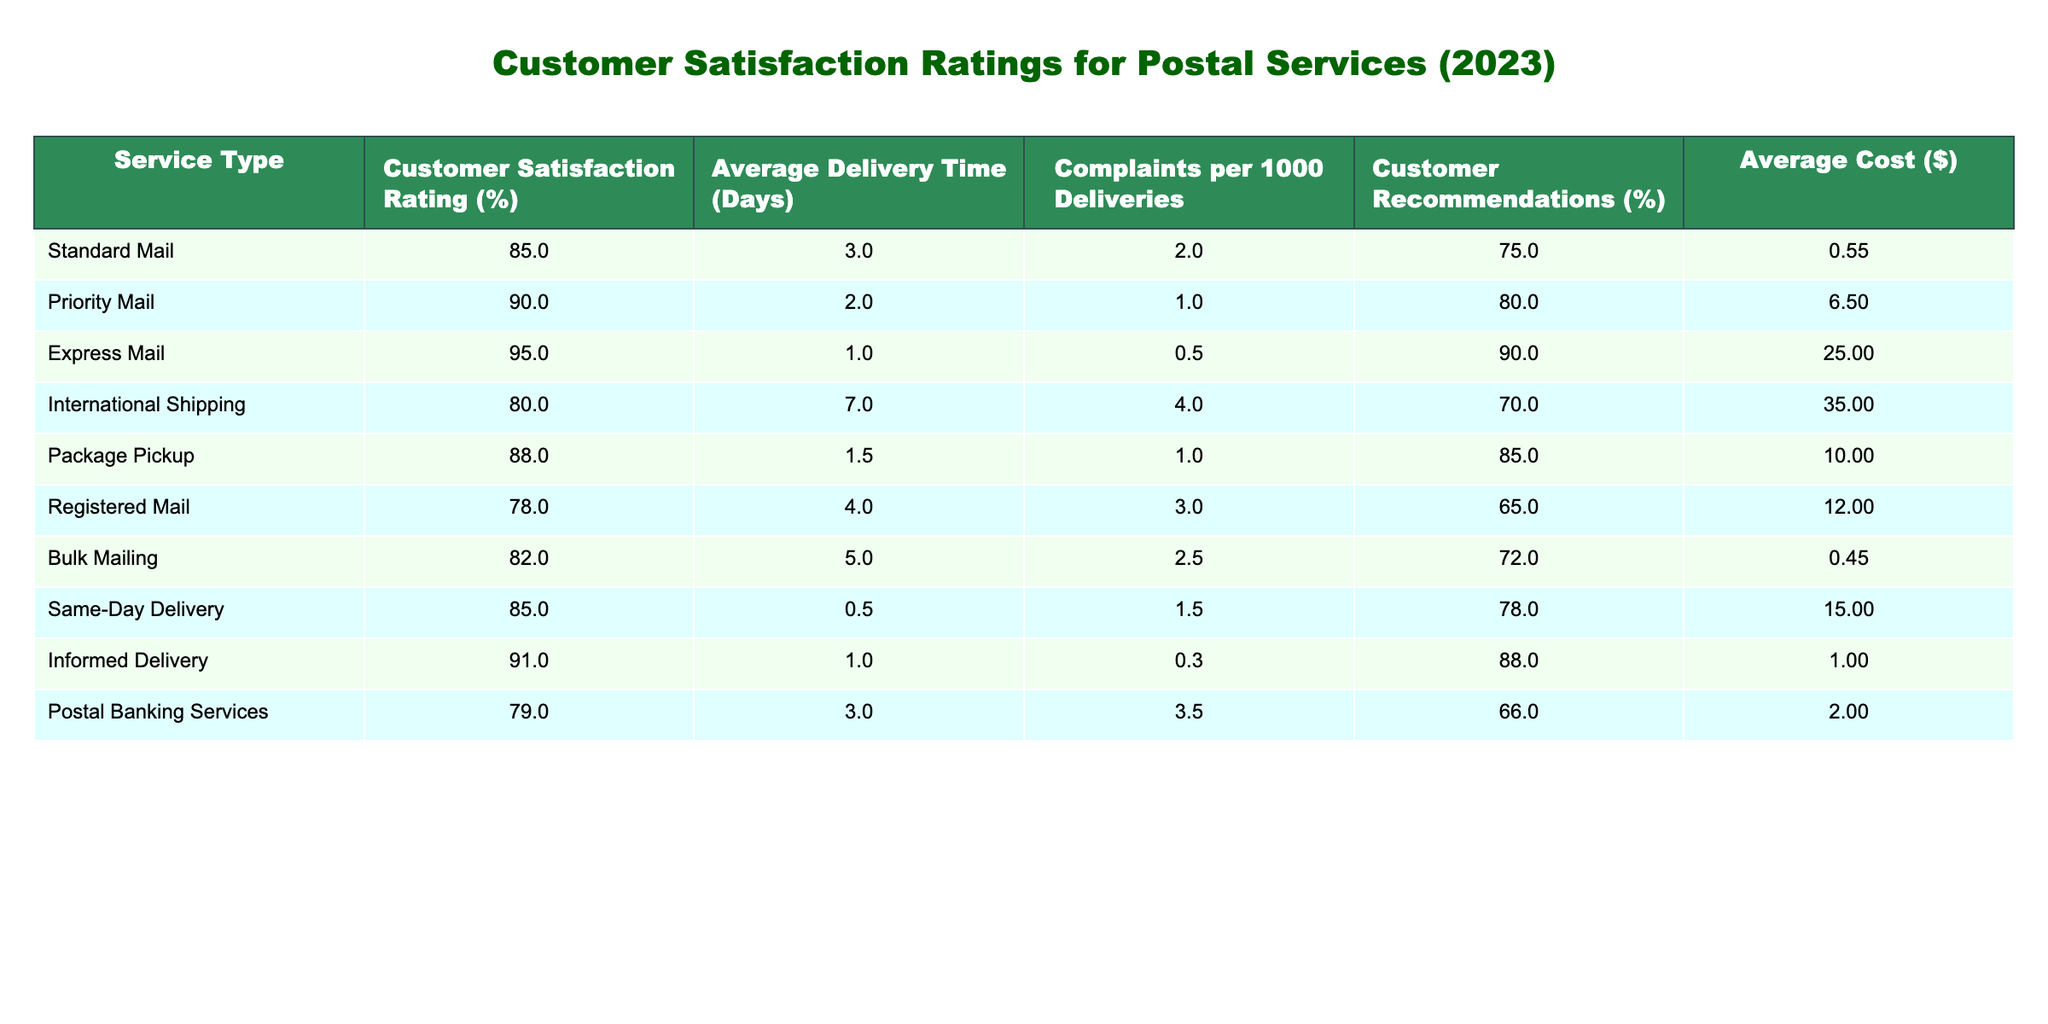What is the customer satisfaction rating for Express Mail? The customer satisfaction rating for Express Mail is shown directly in the table. It displays "95%" under the "Customer Satisfaction Rating (%)" column for the "Express Mail" row.
Answer: 95% Which service type has the highest average delivery time? To find the service with the highest average delivery time, I look through the "Average Delivery Time (Days)" column. The maximum value is "7" for "International Shipping."
Answer: International Shipping How many complaints per 1000 deliveries does Priority Mail have? The number of complaints per 1000 deliveries for Priority Mail can be found in its row under the "Complaints per 1000 Deliveries" column, which shows "1."
Answer: 1 Is the customer satisfaction rating for Same-Day Delivery higher than that for Standard Mail? Comparing the satisfaction ratings, Same-Day Delivery has a rating of "85%" and Standard Mail also has "85%. Therefore, they are equal, not higher.
Answer: No What is the average customer satisfaction rating for all types of services? The average customer satisfaction rating is computed by adding all ratings (85 + 90 + 95 + 80 + 88 + 78 + 82 + 85 + 91 + 79 =  86.8) and dividing by the total number of service types (10).
Answer: 86.8 Which service type has both the highest customer satisfaction rating and the lowest average delivery time? Express Mail has the highest satisfaction rating at "95%" with the lowest delivery time of "1" day. Checking other entries confirms no service exceeds these values.
Answer: Express Mail What percentage of customers recommended the Package Pickup service? In the row for Package Pickup, the "Customer Recommendations (%)" column shows "85%." This directly answers the question without any calculations required.
Answer: 85% Is there a service type that has both an average delivery time of 3 days and a customer satisfaction rating below 80%? The row for Registered Mail indicates 4 days with a rating of 78%. However, there is no service with precisely 3 days and a rating below 80%.
Answer: No What is the difference in customer satisfaction ratings between Express Mail and International Shipping? The satisfaction rating for Express Mail is "95%" and for International Shipping is "80%." The difference is calculated as 95 - 80 = 15.
Answer: 15 Which service type has the highest average cost? Looking at the "Average Cost ($)" column, Express Mail at $25.00 is the highest. There's no service listed with a higher average cost than this.
Answer: Express Mail 